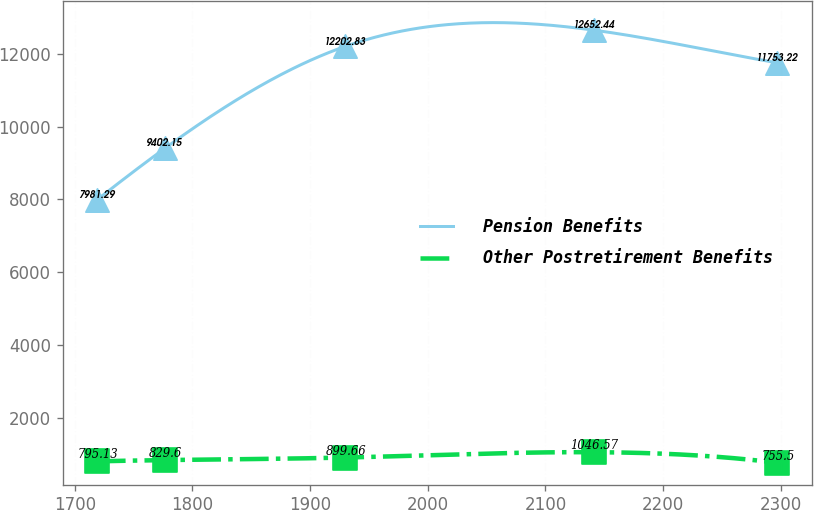<chart> <loc_0><loc_0><loc_500><loc_500><line_chart><ecel><fcel>Pension Benefits<fcel>Other Postretirement Benefits<nl><fcel>1718.77<fcel>7981.29<fcel>795.13<nl><fcel>1776.61<fcel>9402.15<fcel>829.6<nl><fcel>1929.63<fcel>12202.8<fcel>899.66<nl><fcel>2141.14<fcel>12652.4<fcel>1046.57<nl><fcel>2297.15<fcel>11753.2<fcel>755.5<nl></chart> 